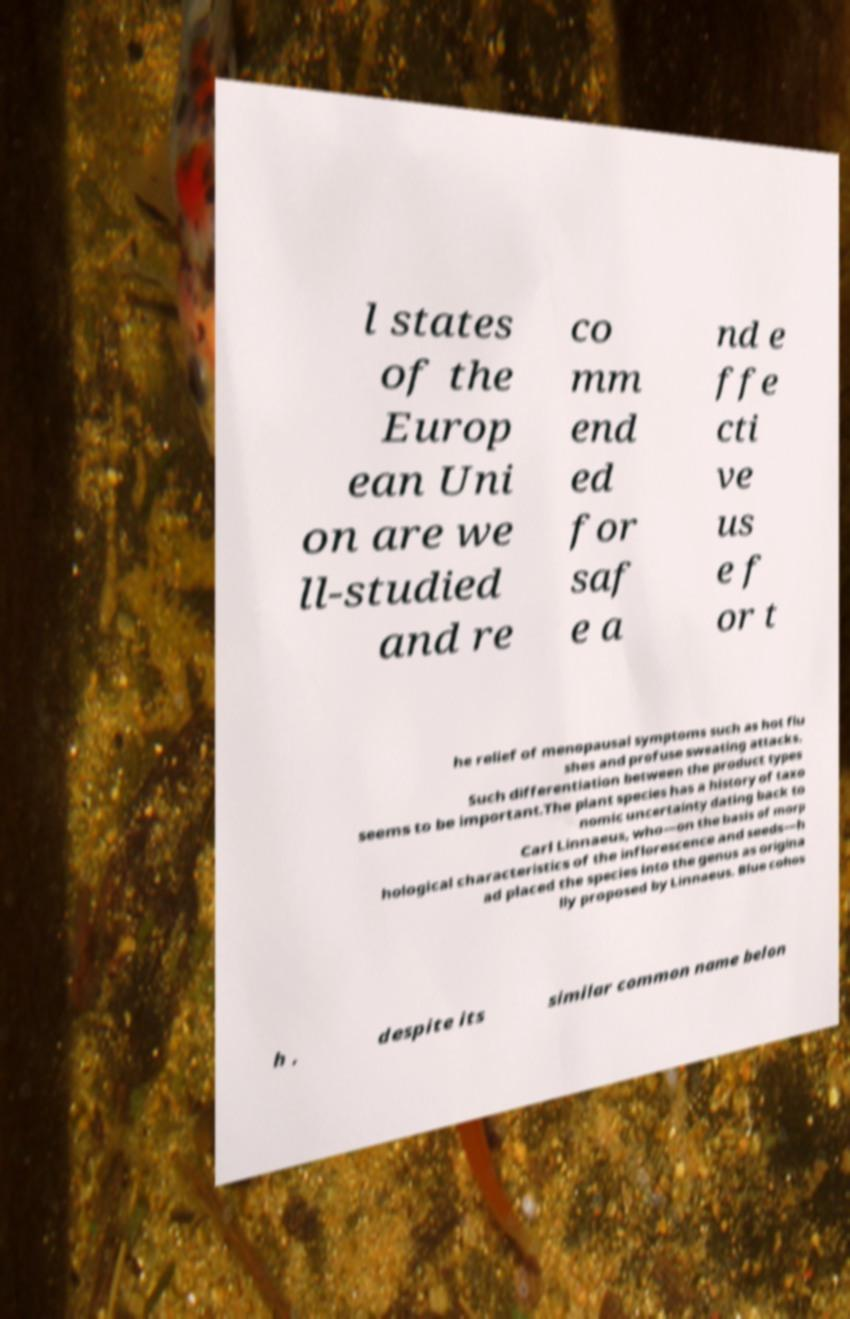Could you assist in decoding the text presented in this image and type it out clearly? l states of the Europ ean Uni on are we ll-studied and re co mm end ed for saf e a nd e ffe cti ve us e f or t he relief of menopausal symptoms such as hot flu shes and profuse sweating attacks. Such differentiation between the product types seems to be important.The plant species has a history of taxo nomic uncertainty dating back to Carl Linnaeus, who—on the basis of morp hological characteristics of the inflorescence and seeds—h ad placed the species into the genus as origina lly proposed by Linnaeus. Blue cohos h , despite its similar common name belon 